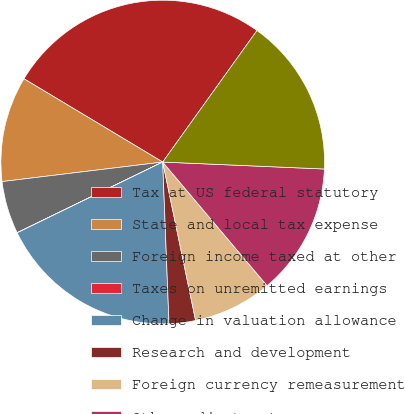Convert chart. <chart><loc_0><loc_0><loc_500><loc_500><pie_chart><fcel>Tax at US federal statutory<fcel>State and local tax expense<fcel>Foreign income taxed at other<fcel>Taxes on unremitted earnings<fcel>Change in valuation allowance<fcel>Research and development<fcel>Foreign currency remeasurement<fcel>Other adjustments<fcel>Total income tax expense<nl><fcel>26.3%<fcel>10.53%<fcel>5.27%<fcel>0.01%<fcel>18.42%<fcel>2.64%<fcel>7.9%<fcel>13.16%<fcel>15.79%<nl></chart> 